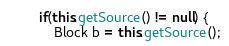Convert code to text. <code><loc_0><loc_0><loc_500><loc_500><_Java_>		if(this.getSource() != null) {
			Block b = this.getSource();</code> 